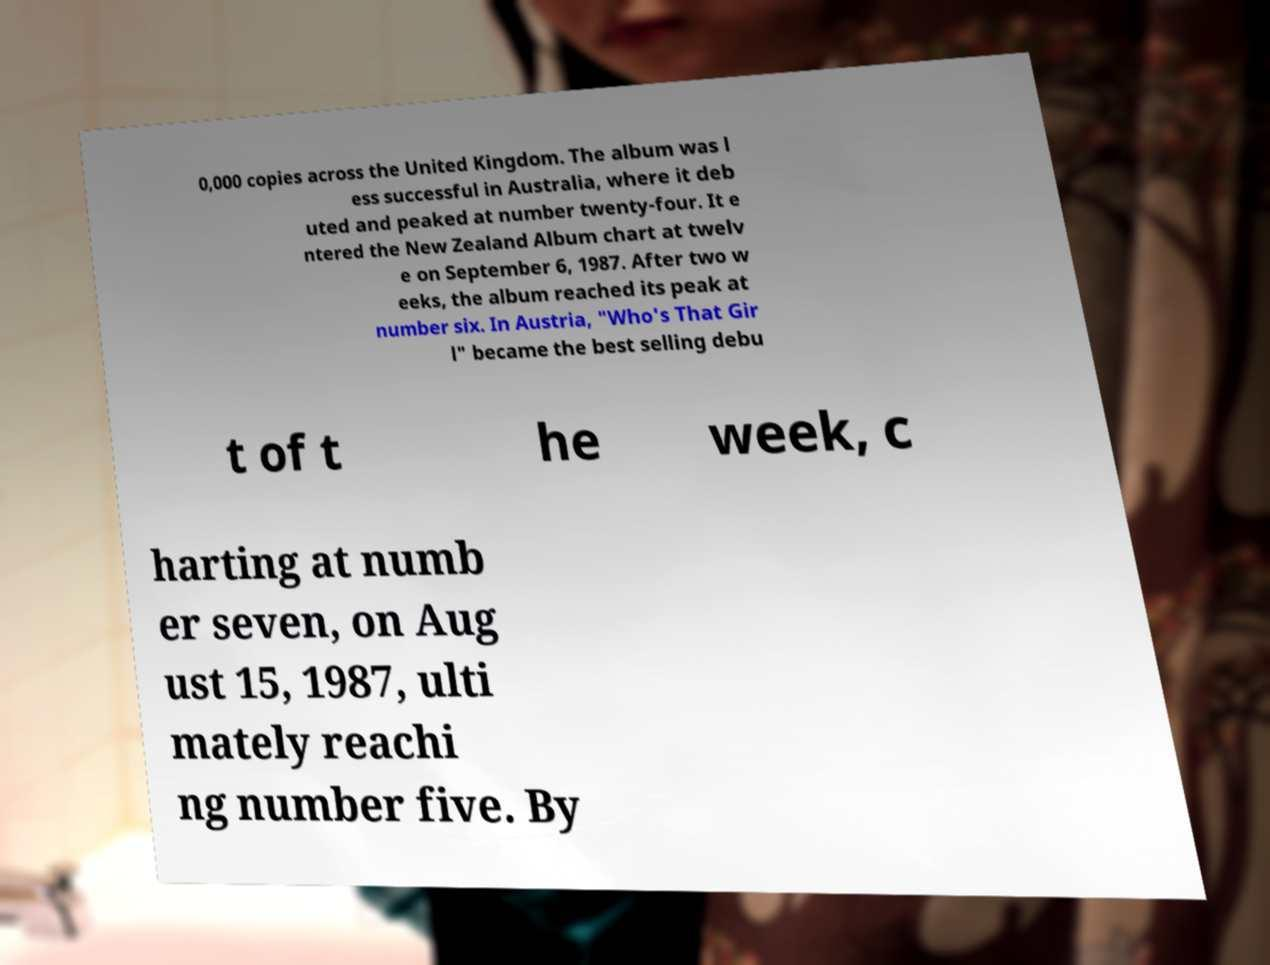Can you read and provide the text displayed in the image?This photo seems to have some interesting text. Can you extract and type it out for me? 0,000 copies across the United Kingdom. The album was l ess successful in Australia, where it deb uted and peaked at number twenty-four. It e ntered the New Zealand Album chart at twelv e on September 6, 1987. After two w eeks, the album reached its peak at number six. In Austria, "Who's That Gir l" became the best selling debu t of t he week, c harting at numb er seven, on Aug ust 15, 1987, ulti mately reachi ng number five. By 